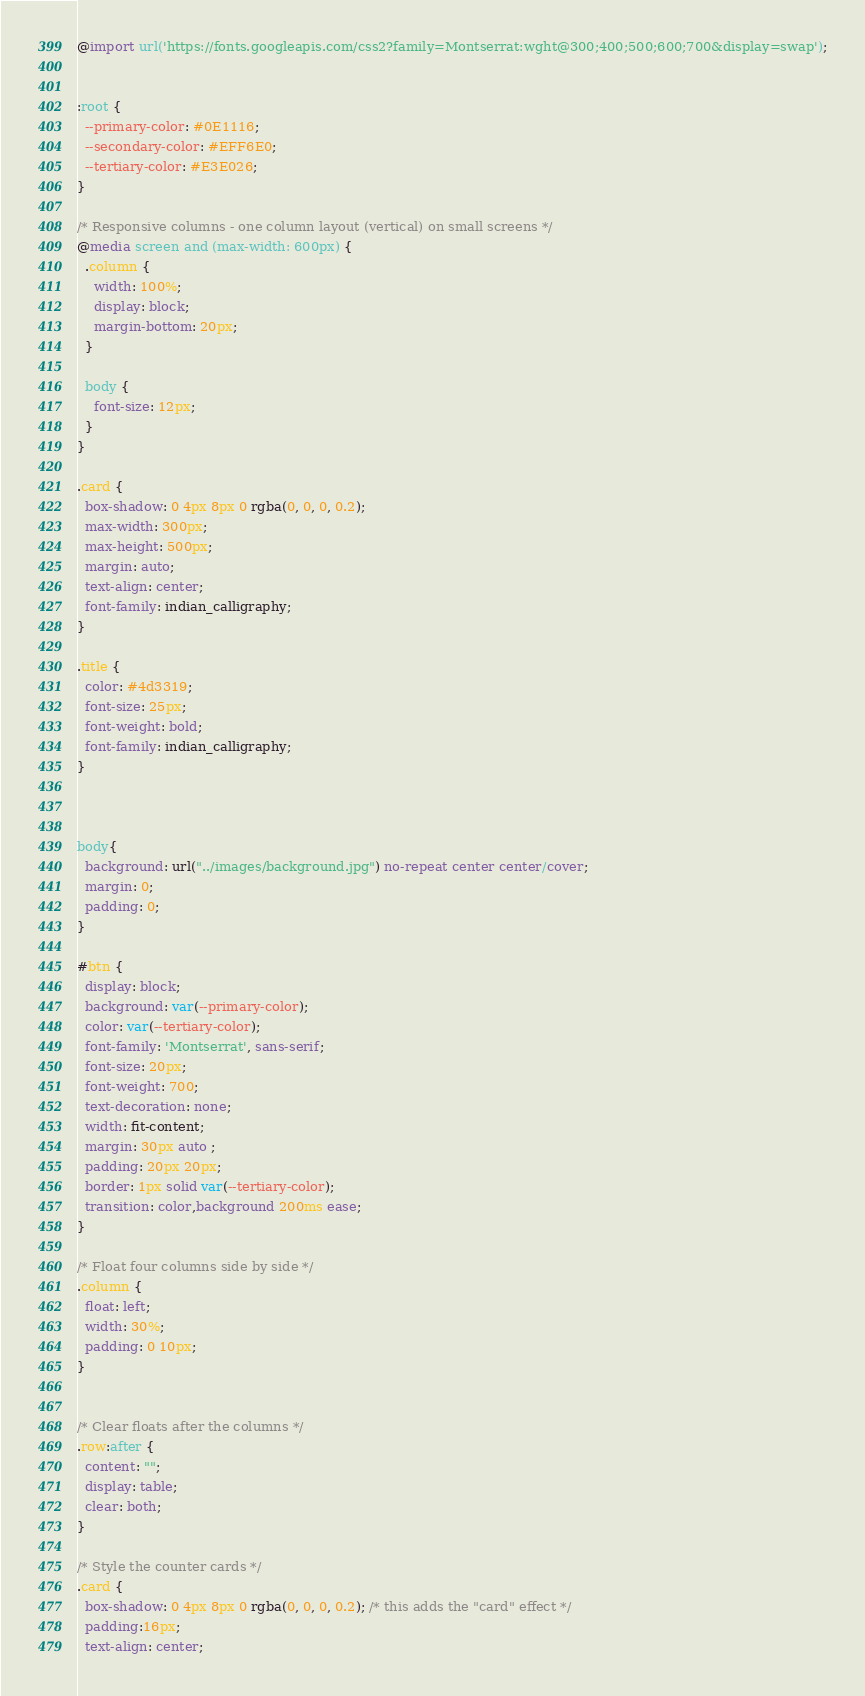<code> <loc_0><loc_0><loc_500><loc_500><_CSS_>@import url('https://fonts.googleapis.com/css2?family=Montserrat:wght@300;400;500;600;700&display=swap');


:root {
  --primary-color: #0E1116;
  --secondary-color: #EFF6E0;
  --tertiary-color: #E3E026;
}

/* Responsive columns - one column layout (vertical) on small screens */
@media screen and (max-width: 600px) {
  .column {
    width: 100%;
    display: block;
    margin-bottom: 20px;
  }

  body {
    font-size: 12px;
  }
}

.card {
  box-shadow: 0 4px 8px 0 rgba(0, 0, 0, 0.2);
  max-width: 300px;
  max-height: 500px;
  margin: auto;
  text-align: center;
  font-family: indian_calligraphy;
}

.title {
  color: #4d3319;
  font-size: 25px;
  font-weight: bold;
  font-family: indian_calligraphy;
}



body{
  background: url("../images/background.jpg") no-repeat center center/cover;
  margin: 0;
  padding: 0;
}

#btn {
  display: block;
  background: var(--primary-color);
  color: var(--tertiary-color);
  font-family: 'Montserrat', sans-serif;
  font-size: 20px;
  font-weight: 700;
  text-decoration: none;
  width: fit-content;
  margin: 30px auto ;
  padding: 20px 20px;
  border: 1px solid var(--tertiary-color);
  transition: color,background 200ms ease;
}

/* Float four columns side by side */
.column {
  float: left;
  width: 30%;
  padding: 0 10px;
}


/* Clear floats after the columns */
.row:after {
  content: "";
  display: table;
  clear: both;
}

/* Style the counter cards */
.card {
  box-shadow: 0 4px 8px 0 rgba(0, 0, 0, 0.2); /* this adds the "card" effect */
  padding:16px;
  text-align: center;</code> 